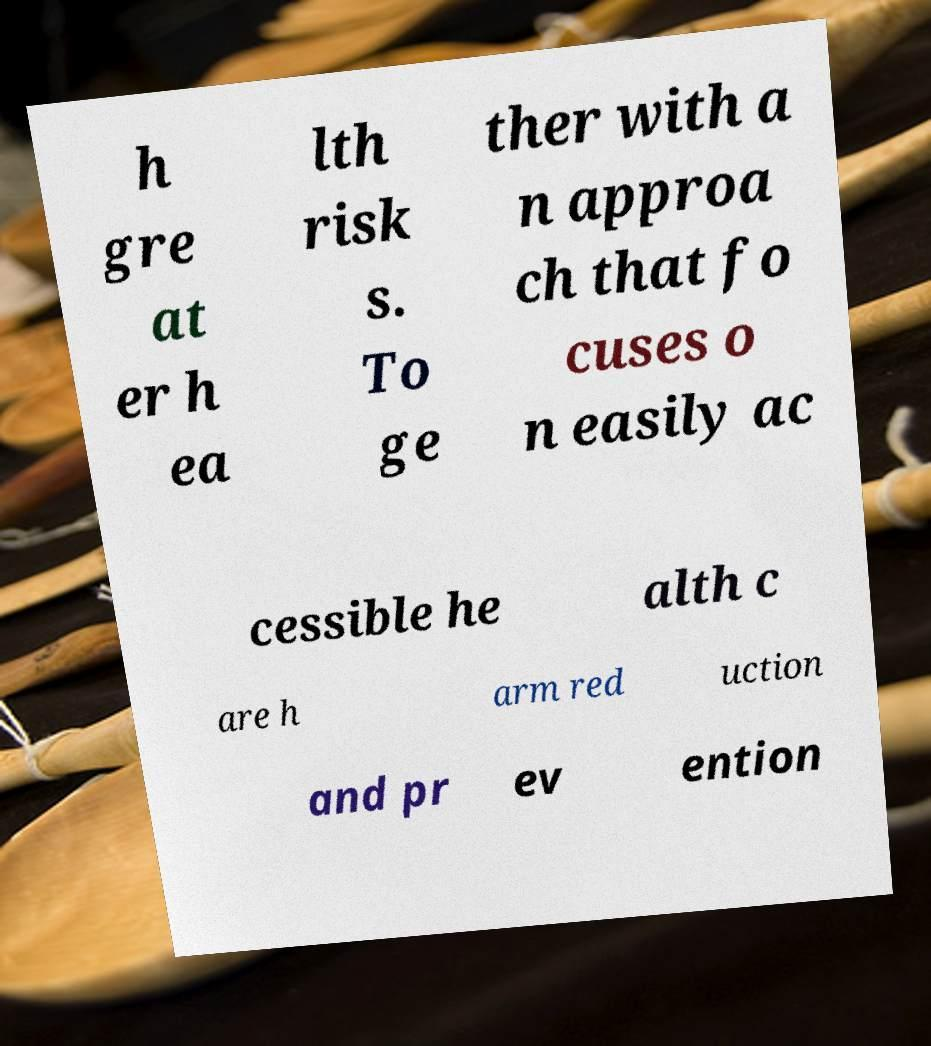For documentation purposes, I need the text within this image transcribed. Could you provide that? h gre at er h ea lth risk s. To ge ther with a n approa ch that fo cuses o n easily ac cessible he alth c are h arm red uction and pr ev ention 